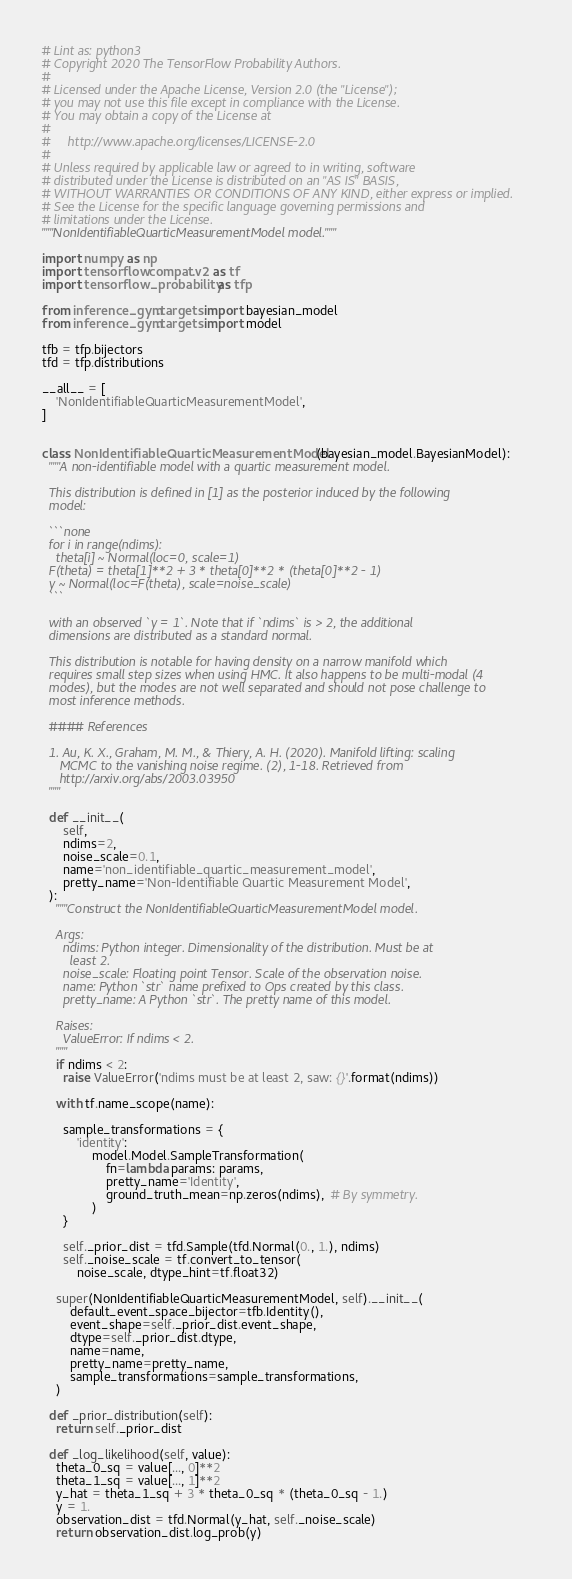<code> <loc_0><loc_0><loc_500><loc_500><_Python_># Lint as: python3
# Copyright 2020 The TensorFlow Probability Authors.
#
# Licensed under the Apache License, Version 2.0 (the "License");
# you may not use this file except in compliance with the License.
# You may obtain a copy of the License at
#
#     http://www.apache.org/licenses/LICENSE-2.0
#
# Unless required by applicable law or agreed to in writing, software
# distributed under the License is distributed on an "AS IS" BASIS,
# WITHOUT WARRANTIES OR CONDITIONS OF ANY KIND, either express or implied.
# See the License for the specific language governing permissions and
# limitations under the License.
"""NonIdentifiableQuarticMeasurementModel model."""

import numpy as np
import tensorflow.compat.v2 as tf
import tensorflow_probability as tfp

from inference_gym.targets import bayesian_model
from inference_gym.targets import model

tfb = tfp.bijectors
tfd = tfp.distributions

__all__ = [
    'NonIdentifiableQuarticMeasurementModel',
]


class NonIdentifiableQuarticMeasurementModel(bayesian_model.BayesianModel):
  """A non-identifiable model with a quartic measurement model.

  This distribution is defined in [1] as the posterior induced by the following
  model:

  ```none
  for i in range(ndims):
    theta[i] ~ Normal(loc=0, scale=1)
  F(theta) = theta[1]**2 + 3 * theta[0]**2 * (theta[0]**2 - 1)
  y ~ Normal(loc=F(theta), scale=noise_scale)
  ```

  with an observed `y = 1`. Note that if `ndims` is > 2, the additional
  dimensions are distributed as a standard normal.

  This distribution is notable for having density on a narrow manifold which
  requires small step sizes when using HMC. It also happens to be multi-modal (4
  modes), but the modes are not well separated and should not pose challenge to
  most inference methods.

  #### References

  1. Au, K. X., Graham, M. M., & Thiery, A. H. (2020). Manifold lifting: scaling
     MCMC to the vanishing noise regime. (2), 1-18. Retrieved from
     http://arxiv.org/abs/2003.03950
  """

  def __init__(
      self,
      ndims=2,
      noise_scale=0.1,
      name='non_identifiable_quartic_measurement_model',
      pretty_name='Non-Identifiable Quartic Measurement Model',
  ):
    """Construct the NonIdentifiableQuarticMeasurementModel model.

    Args:
      ndims: Python integer. Dimensionality of the distribution. Must be at
        least 2.
      noise_scale: Floating point Tensor. Scale of the observation noise.
      name: Python `str` name prefixed to Ops created by this class.
      pretty_name: A Python `str`. The pretty name of this model.

    Raises:
      ValueError: If ndims < 2.
    """
    if ndims < 2:
      raise ValueError('ndims must be at least 2, saw: {}'.format(ndims))

    with tf.name_scope(name):

      sample_transformations = {
          'identity':
              model.Model.SampleTransformation(
                  fn=lambda params: params,
                  pretty_name='Identity',
                  ground_truth_mean=np.zeros(ndims),  # By symmetry.
              )
      }

      self._prior_dist = tfd.Sample(tfd.Normal(0., 1.), ndims)
      self._noise_scale = tf.convert_to_tensor(
          noise_scale, dtype_hint=tf.float32)

    super(NonIdentifiableQuarticMeasurementModel, self).__init__(
        default_event_space_bijector=tfb.Identity(),
        event_shape=self._prior_dist.event_shape,
        dtype=self._prior_dist.dtype,
        name=name,
        pretty_name=pretty_name,
        sample_transformations=sample_transformations,
    )

  def _prior_distribution(self):
    return self._prior_dist

  def _log_likelihood(self, value):
    theta_0_sq = value[..., 0]**2
    theta_1_sq = value[..., 1]**2
    y_hat = theta_1_sq + 3 * theta_0_sq * (theta_0_sq - 1.)
    y = 1.
    observation_dist = tfd.Normal(y_hat, self._noise_scale)
    return observation_dist.log_prob(y)
</code> 